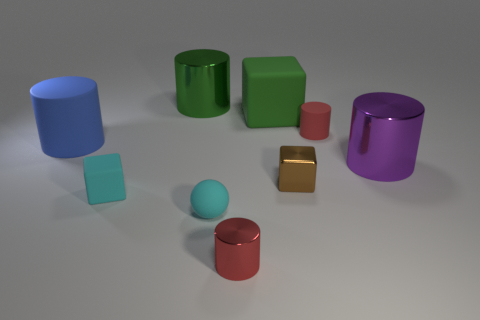Subtract all matte blocks. How many blocks are left? 1 Subtract all spheres. How many objects are left? 8 Subtract 1 cubes. How many cubes are left? 2 Subtract all blue cylinders. How many cylinders are left? 4 Add 4 big blue matte cylinders. How many big blue matte cylinders are left? 5 Add 6 large purple shiny cylinders. How many large purple shiny cylinders exist? 7 Add 1 small purple rubber things. How many objects exist? 10 Subtract 1 cyan cubes. How many objects are left? 8 Subtract all gray cylinders. Subtract all brown balls. How many cylinders are left? 5 Subtract all red blocks. How many red cylinders are left? 2 